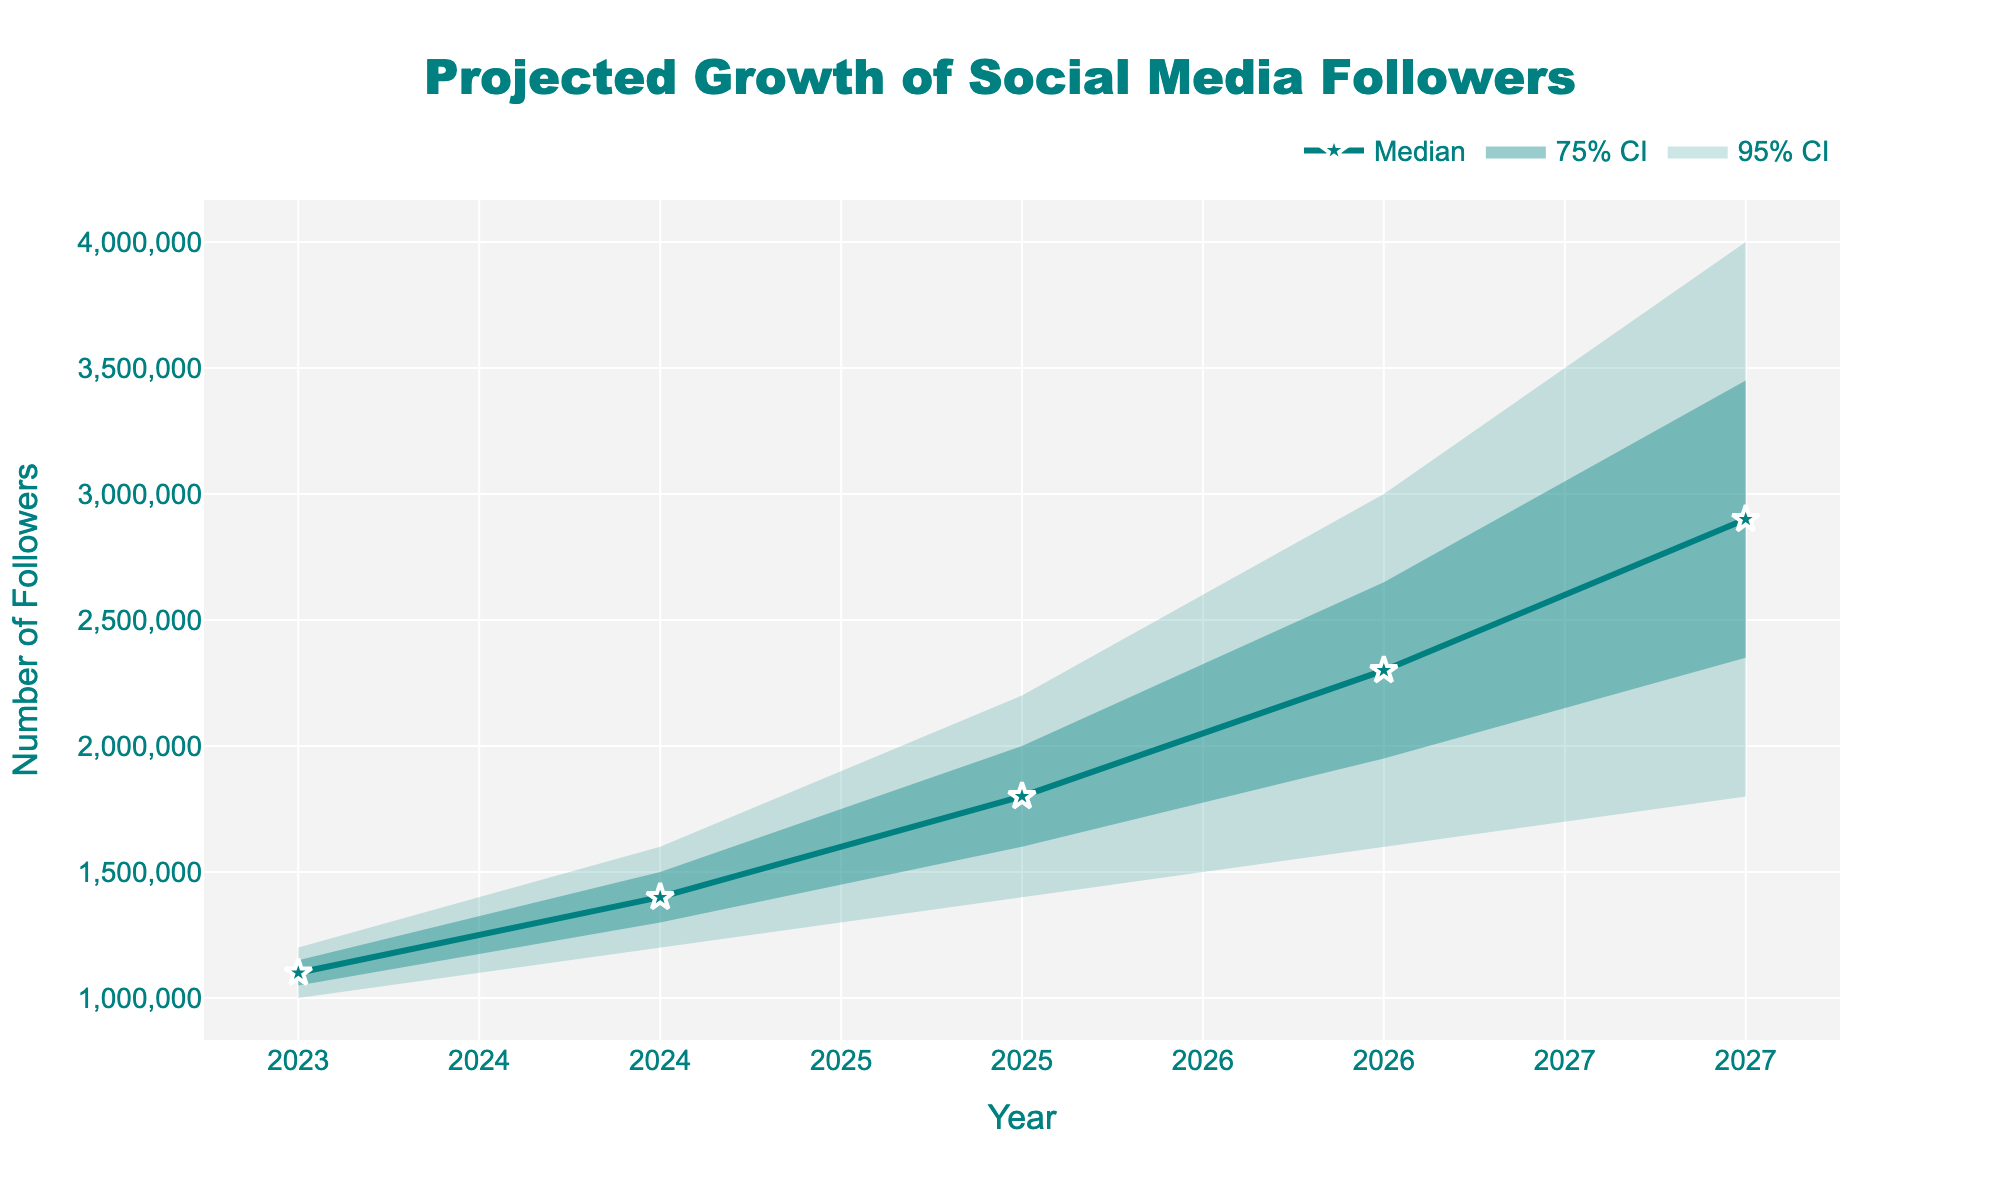What is the title of the chart? The title of the chart is placed prominently at the top to provide context. It reads: "Projected Growth of Social Media Followers".
Answer: Projected Growth of Social Media Followers What does the y-axis represent? The y-axis represents the number of followers over time, as indicated by the label "Number of Followers".
Answer: Number of Followers How many years are included in the projection? We can count the number of data points along the x-axis, which represents each year from 2023 to 2027.
Answer: 5 What is the projected median number of followers in 2027? The median line for the year 2027 intersects at 2,900,000 followers. The median line is shown as a solid line with markers.
Answer: 2,900,000 What is the range of the 95% confidence interval for the year 2024? The 95% confidence interval in 2024 spans from the lower bound of 1,200,000 followers to the upper bound of 1,600,000 followers.
Answer: 1,200,000 to 1,600,000 followers By how much is the median projected to increase from 2023 to 2027? The median value in 2023 is 1,100,000 followers and in 2027 it is 2,900,000 followers. The difference is 2,900,000 - 1,100,000.
Answer: 1,800,000 In which year is the gap between the median projection and the upper 75% confidence interval the largest? By visually inspecting the distances between the median line and the upper 75% confidence interval, the largest gap occurs in the year 2027.
Answer: 2027 What is the lower bound of the 75% confidence interval for 2026? The lower bound of the 75% confidence interval for 2026 is shown as 1,950,000 followers.
Answer: 1,950,000 followers Which year shows the widest range for the 95% confidence interval? By comparing the spans of the 95% confidence interval for each year, 2027 has the widest range, from 1,800,000 to 4,000,000 followers.
Answer: 2027 Does the upper 95% confidence interval reach 4,000,000 followers in any year? Yes, the upper 95% confidence interval reaches exactly 4,000,000 followers in the year 2027, as indicated in the data.
Answer: Yes 